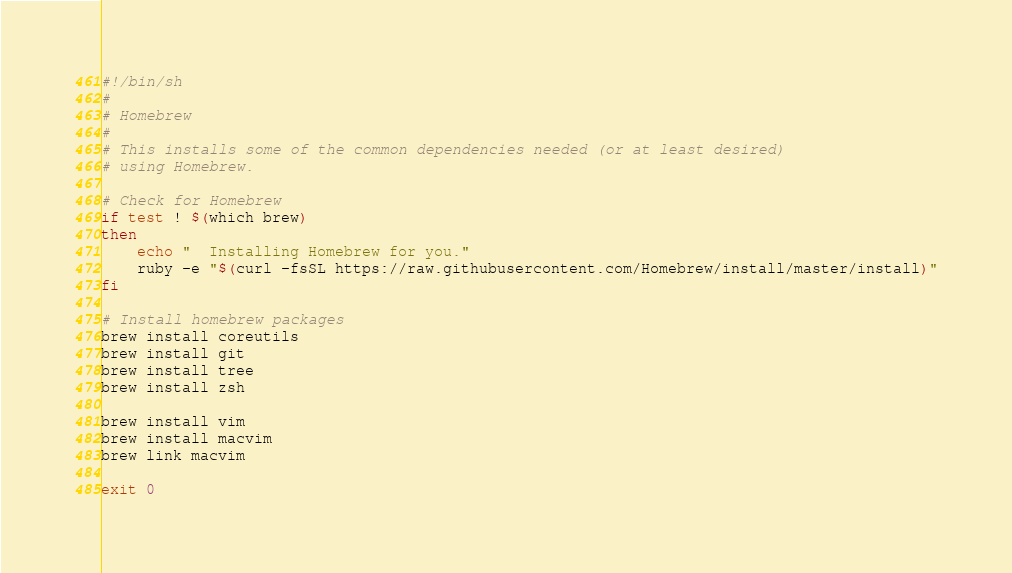Convert code to text. <code><loc_0><loc_0><loc_500><loc_500><_Bash_>#!/bin/sh
#
# Homebrew
#
# This installs some of the common dependencies needed (or at least desired)
# using Homebrew.

# Check for Homebrew
if test ! $(which brew)
then
    echo "  Installing Homebrew for you."
    ruby -e "$(curl -fsSL https://raw.githubusercontent.com/Homebrew/install/master/install)"
fi

# Install homebrew packages
brew install coreutils 
brew install git 
brew install tree
brew install zsh

brew install vim
brew install macvim
brew link macvim

exit 0
</code> 